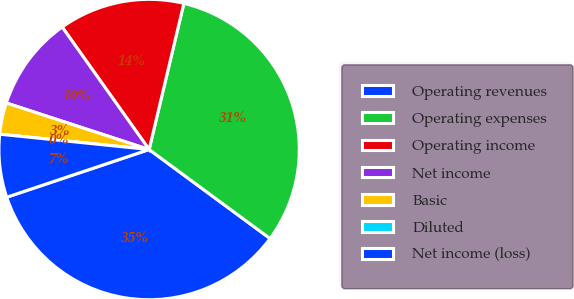<chart> <loc_0><loc_0><loc_500><loc_500><pie_chart><fcel>Operating revenues<fcel>Operating expenses<fcel>Operating income<fcel>Net income<fcel>Basic<fcel>Diluted<fcel>Net income (loss)<nl><fcel>34.76%<fcel>31.38%<fcel>13.54%<fcel>10.16%<fcel>3.39%<fcel>0.0%<fcel>6.77%<nl></chart> 